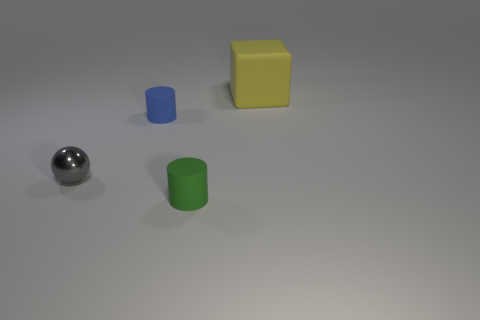Subtract all purple balls. Subtract all purple cylinders. How many balls are left? 1 Add 4 metal spheres. How many objects exist? 8 Subtract all cubes. How many objects are left? 3 Add 1 big rubber cubes. How many big rubber cubes exist? 2 Subtract 0 cyan spheres. How many objects are left? 4 Subtract all small gray metal objects. Subtract all large brown metal spheres. How many objects are left? 3 Add 2 small gray balls. How many small gray balls are left? 3 